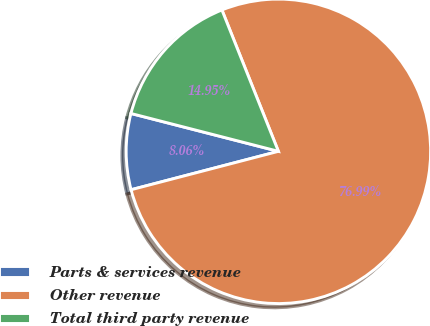Convert chart. <chart><loc_0><loc_0><loc_500><loc_500><pie_chart><fcel>Parts & services revenue<fcel>Other revenue<fcel>Total third party revenue<nl><fcel>8.06%<fcel>76.99%<fcel>14.95%<nl></chart> 